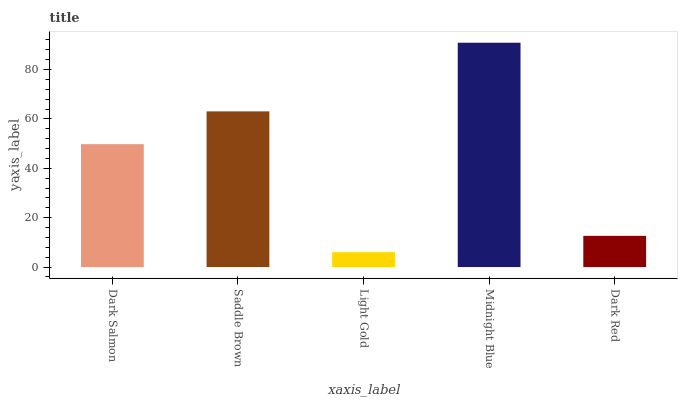Is Light Gold the minimum?
Answer yes or no. Yes. Is Midnight Blue the maximum?
Answer yes or no. Yes. Is Saddle Brown the minimum?
Answer yes or no. No. Is Saddle Brown the maximum?
Answer yes or no. No. Is Saddle Brown greater than Dark Salmon?
Answer yes or no. Yes. Is Dark Salmon less than Saddle Brown?
Answer yes or no. Yes. Is Dark Salmon greater than Saddle Brown?
Answer yes or no. No. Is Saddle Brown less than Dark Salmon?
Answer yes or no. No. Is Dark Salmon the high median?
Answer yes or no. Yes. Is Dark Salmon the low median?
Answer yes or no. Yes. Is Light Gold the high median?
Answer yes or no. No. Is Saddle Brown the low median?
Answer yes or no. No. 